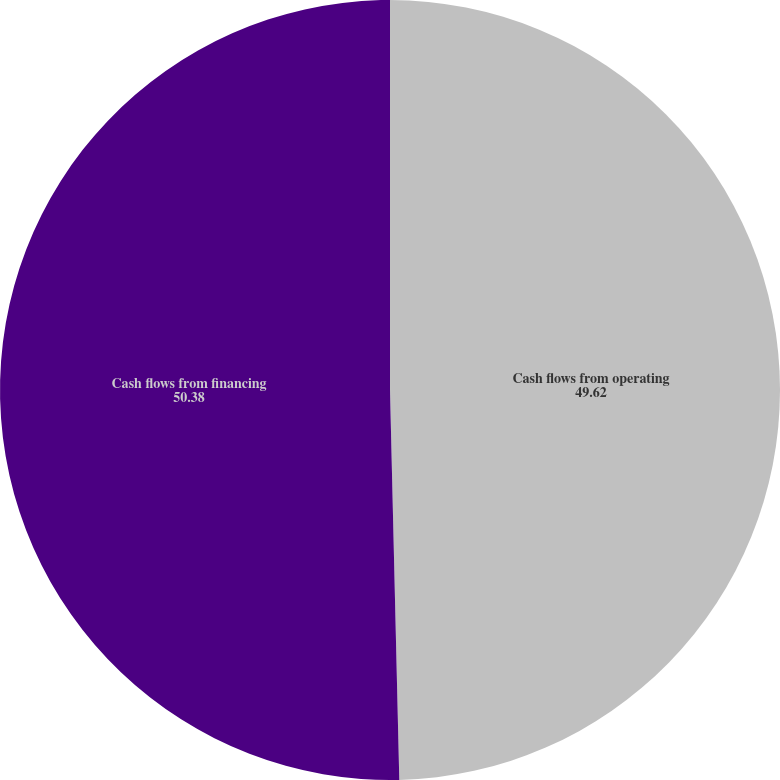Convert chart. <chart><loc_0><loc_0><loc_500><loc_500><pie_chart><fcel>Cash flows from operating<fcel>Cash flows from financing<nl><fcel>49.62%<fcel>50.38%<nl></chart> 